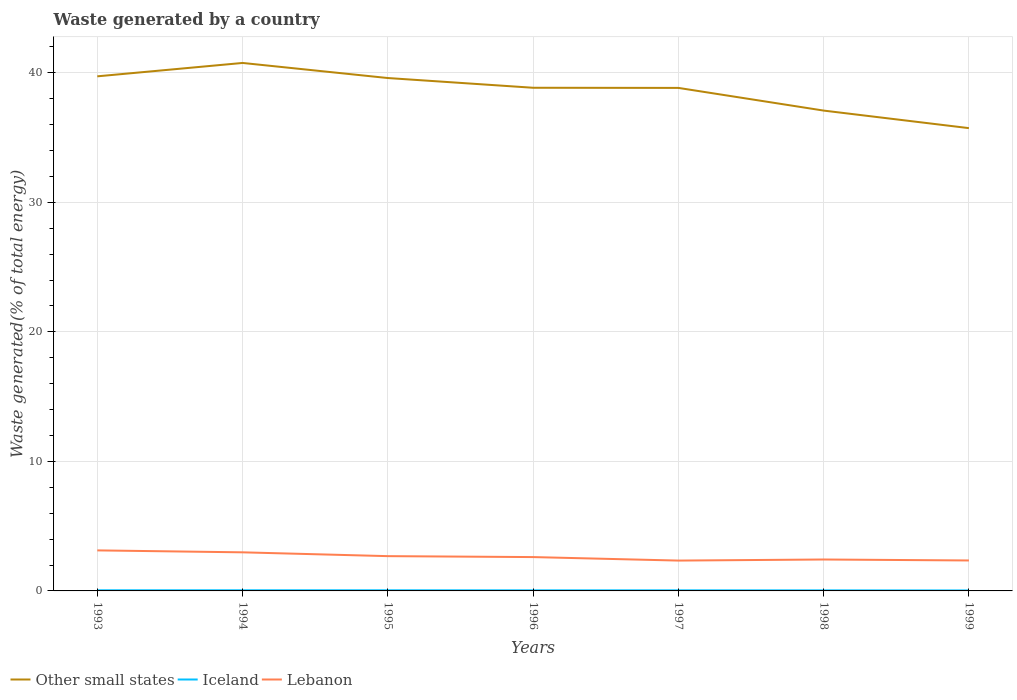How many different coloured lines are there?
Keep it short and to the point. 3. Across all years, what is the maximum total waste generated in Iceland?
Make the answer very short. 0.04. In which year was the total waste generated in Lebanon maximum?
Your answer should be compact. 1997. What is the total total waste generated in Other small states in the graph?
Provide a succinct answer. 2.64. What is the difference between the highest and the second highest total waste generated in Other small states?
Give a very brief answer. 5.03. How many lines are there?
Provide a short and direct response. 3. How many years are there in the graph?
Give a very brief answer. 7. What is the difference between two consecutive major ticks on the Y-axis?
Your answer should be compact. 10. Are the values on the major ticks of Y-axis written in scientific E-notation?
Offer a terse response. No. Does the graph contain any zero values?
Offer a terse response. No. What is the title of the graph?
Offer a very short reply. Waste generated by a country. What is the label or title of the Y-axis?
Make the answer very short. Waste generated(% of total energy). What is the Waste generated(% of total energy) of Other small states in 1993?
Your answer should be compact. 39.73. What is the Waste generated(% of total energy) of Iceland in 1993?
Make the answer very short. 0.05. What is the Waste generated(% of total energy) in Lebanon in 1993?
Provide a short and direct response. 3.13. What is the Waste generated(% of total energy) in Other small states in 1994?
Your response must be concise. 40.76. What is the Waste generated(% of total energy) in Iceland in 1994?
Keep it short and to the point. 0.05. What is the Waste generated(% of total energy) of Lebanon in 1994?
Provide a short and direct response. 2.98. What is the Waste generated(% of total energy) in Other small states in 1995?
Keep it short and to the point. 39.6. What is the Waste generated(% of total energy) in Iceland in 1995?
Keep it short and to the point. 0.05. What is the Waste generated(% of total energy) of Lebanon in 1995?
Offer a terse response. 2.69. What is the Waste generated(% of total energy) in Other small states in 1996?
Provide a short and direct response. 38.85. What is the Waste generated(% of total energy) in Iceland in 1996?
Offer a terse response. 0.05. What is the Waste generated(% of total energy) of Lebanon in 1996?
Make the answer very short. 2.61. What is the Waste generated(% of total energy) in Other small states in 1997?
Your answer should be compact. 38.84. What is the Waste generated(% of total energy) in Iceland in 1997?
Provide a short and direct response. 0.04. What is the Waste generated(% of total energy) in Lebanon in 1997?
Ensure brevity in your answer.  2.34. What is the Waste generated(% of total energy) of Other small states in 1998?
Your answer should be very brief. 37.09. What is the Waste generated(% of total energy) in Iceland in 1998?
Offer a very short reply. 0.04. What is the Waste generated(% of total energy) of Lebanon in 1998?
Keep it short and to the point. 2.43. What is the Waste generated(% of total energy) of Other small states in 1999?
Provide a short and direct response. 35.73. What is the Waste generated(% of total energy) in Iceland in 1999?
Your answer should be compact. 0.04. What is the Waste generated(% of total energy) in Lebanon in 1999?
Keep it short and to the point. 2.35. Across all years, what is the maximum Waste generated(% of total energy) in Other small states?
Offer a very short reply. 40.76. Across all years, what is the maximum Waste generated(% of total energy) in Iceland?
Ensure brevity in your answer.  0.05. Across all years, what is the maximum Waste generated(% of total energy) in Lebanon?
Your response must be concise. 3.13. Across all years, what is the minimum Waste generated(% of total energy) of Other small states?
Provide a succinct answer. 35.73. Across all years, what is the minimum Waste generated(% of total energy) of Iceland?
Give a very brief answer. 0.04. Across all years, what is the minimum Waste generated(% of total energy) of Lebanon?
Give a very brief answer. 2.34. What is the total Waste generated(% of total energy) of Other small states in the graph?
Keep it short and to the point. 270.6. What is the total Waste generated(% of total energy) of Iceland in the graph?
Your response must be concise. 0.31. What is the total Waste generated(% of total energy) in Lebanon in the graph?
Keep it short and to the point. 18.53. What is the difference between the Waste generated(% of total energy) of Other small states in 1993 and that in 1994?
Keep it short and to the point. -1.03. What is the difference between the Waste generated(% of total energy) in Lebanon in 1993 and that in 1994?
Your response must be concise. 0.15. What is the difference between the Waste generated(% of total energy) in Other small states in 1993 and that in 1995?
Your response must be concise. 0.13. What is the difference between the Waste generated(% of total energy) of Iceland in 1993 and that in 1995?
Make the answer very short. 0. What is the difference between the Waste generated(% of total energy) of Lebanon in 1993 and that in 1995?
Offer a very short reply. 0.44. What is the difference between the Waste generated(% of total energy) in Other small states in 1993 and that in 1996?
Your answer should be very brief. 0.88. What is the difference between the Waste generated(% of total energy) in Iceland in 1993 and that in 1996?
Your answer should be compact. 0. What is the difference between the Waste generated(% of total energy) in Lebanon in 1993 and that in 1996?
Provide a succinct answer. 0.52. What is the difference between the Waste generated(% of total energy) of Other small states in 1993 and that in 1997?
Offer a very short reply. 0.89. What is the difference between the Waste generated(% of total energy) of Iceland in 1993 and that in 1997?
Give a very brief answer. 0.01. What is the difference between the Waste generated(% of total energy) in Lebanon in 1993 and that in 1997?
Keep it short and to the point. 0.79. What is the difference between the Waste generated(% of total energy) in Other small states in 1993 and that in 1998?
Your answer should be very brief. 2.64. What is the difference between the Waste generated(% of total energy) in Iceland in 1993 and that in 1998?
Offer a very short reply. 0.01. What is the difference between the Waste generated(% of total energy) of Lebanon in 1993 and that in 1998?
Make the answer very short. 0.7. What is the difference between the Waste generated(% of total energy) of Other small states in 1993 and that in 1999?
Give a very brief answer. 4. What is the difference between the Waste generated(% of total energy) in Iceland in 1993 and that in 1999?
Keep it short and to the point. 0.01. What is the difference between the Waste generated(% of total energy) of Lebanon in 1993 and that in 1999?
Give a very brief answer. 0.78. What is the difference between the Waste generated(% of total energy) in Other small states in 1994 and that in 1995?
Keep it short and to the point. 1.16. What is the difference between the Waste generated(% of total energy) of Iceland in 1994 and that in 1995?
Your answer should be compact. 0. What is the difference between the Waste generated(% of total energy) of Lebanon in 1994 and that in 1995?
Your response must be concise. 0.29. What is the difference between the Waste generated(% of total energy) of Other small states in 1994 and that in 1996?
Your answer should be compact. 1.92. What is the difference between the Waste generated(% of total energy) in Iceland in 1994 and that in 1996?
Give a very brief answer. 0. What is the difference between the Waste generated(% of total energy) of Lebanon in 1994 and that in 1996?
Give a very brief answer. 0.37. What is the difference between the Waste generated(% of total energy) in Other small states in 1994 and that in 1997?
Offer a very short reply. 1.93. What is the difference between the Waste generated(% of total energy) in Iceland in 1994 and that in 1997?
Provide a succinct answer. 0. What is the difference between the Waste generated(% of total energy) of Lebanon in 1994 and that in 1997?
Give a very brief answer. 0.64. What is the difference between the Waste generated(% of total energy) in Other small states in 1994 and that in 1998?
Offer a terse response. 3.68. What is the difference between the Waste generated(% of total energy) of Iceland in 1994 and that in 1998?
Ensure brevity in your answer.  0.01. What is the difference between the Waste generated(% of total energy) in Lebanon in 1994 and that in 1998?
Keep it short and to the point. 0.55. What is the difference between the Waste generated(% of total energy) of Other small states in 1994 and that in 1999?
Offer a terse response. 5.03. What is the difference between the Waste generated(% of total energy) of Iceland in 1994 and that in 1999?
Your response must be concise. 0.01. What is the difference between the Waste generated(% of total energy) of Lebanon in 1994 and that in 1999?
Offer a terse response. 0.63. What is the difference between the Waste generated(% of total energy) of Other small states in 1995 and that in 1996?
Keep it short and to the point. 0.75. What is the difference between the Waste generated(% of total energy) in Iceland in 1995 and that in 1996?
Provide a short and direct response. 0. What is the difference between the Waste generated(% of total energy) of Lebanon in 1995 and that in 1996?
Provide a succinct answer. 0.07. What is the difference between the Waste generated(% of total energy) in Other small states in 1995 and that in 1997?
Provide a short and direct response. 0.76. What is the difference between the Waste generated(% of total energy) in Iceland in 1995 and that in 1997?
Keep it short and to the point. 0. What is the difference between the Waste generated(% of total energy) in Lebanon in 1995 and that in 1997?
Keep it short and to the point. 0.34. What is the difference between the Waste generated(% of total energy) of Other small states in 1995 and that in 1998?
Give a very brief answer. 2.51. What is the difference between the Waste generated(% of total energy) in Iceland in 1995 and that in 1998?
Keep it short and to the point. 0.01. What is the difference between the Waste generated(% of total energy) in Lebanon in 1995 and that in 1998?
Offer a very short reply. 0.26. What is the difference between the Waste generated(% of total energy) of Other small states in 1995 and that in 1999?
Ensure brevity in your answer.  3.87. What is the difference between the Waste generated(% of total energy) of Iceland in 1995 and that in 1999?
Your answer should be compact. 0.01. What is the difference between the Waste generated(% of total energy) in Lebanon in 1995 and that in 1999?
Provide a short and direct response. 0.33. What is the difference between the Waste generated(% of total energy) of Other small states in 1996 and that in 1997?
Keep it short and to the point. 0.01. What is the difference between the Waste generated(% of total energy) of Iceland in 1996 and that in 1997?
Ensure brevity in your answer.  0. What is the difference between the Waste generated(% of total energy) in Lebanon in 1996 and that in 1997?
Your response must be concise. 0.27. What is the difference between the Waste generated(% of total energy) in Other small states in 1996 and that in 1998?
Provide a short and direct response. 1.76. What is the difference between the Waste generated(% of total energy) in Iceland in 1996 and that in 1998?
Give a very brief answer. 0. What is the difference between the Waste generated(% of total energy) of Lebanon in 1996 and that in 1998?
Keep it short and to the point. 0.19. What is the difference between the Waste generated(% of total energy) in Other small states in 1996 and that in 1999?
Your answer should be compact. 3.12. What is the difference between the Waste generated(% of total energy) in Iceland in 1996 and that in 1999?
Offer a very short reply. 0.01. What is the difference between the Waste generated(% of total energy) in Lebanon in 1996 and that in 1999?
Give a very brief answer. 0.26. What is the difference between the Waste generated(% of total energy) of Other small states in 1997 and that in 1998?
Your answer should be very brief. 1.75. What is the difference between the Waste generated(% of total energy) in Iceland in 1997 and that in 1998?
Ensure brevity in your answer.  0. What is the difference between the Waste generated(% of total energy) of Lebanon in 1997 and that in 1998?
Ensure brevity in your answer.  -0.08. What is the difference between the Waste generated(% of total energy) of Other small states in 1997 and that in 1999?
Keep it short and to the point. 3.11. What is the difference between the Waste generated(% of total energy) of Iceland in 1997 and that in 1999?
Give a very brief answer. 0.01. What is the difference between the Waste generated(% of total energy) in Lebanon in 1997 and that in 1999?
Keep it short and to the point. -0.01. What is the difference between the Waste generated(% of total energy) of Other small states in 1998 and that in 1999?
Your response must be concise. 1.36. What is the difference between the Waste generated(% of total energy) of Iceland in 1998 and that in 1999?
Provide a succinct answer. 0.01. What is the difference between the Waste generated(% of total energy) in Lebanon in 1998 and that in 1999?
Offer a terse response. 0.08. What is the difference between the Waste generated(% of total energy) in Other small states in 1993 and the Waste generated(% of total energy) in Iceland in 1994?
Keep it short and to the point. 39.68. What is the difference between the Waste generated(% of total energy) of Other small states in 1993 and the Waste generated(% of total energy) of Lebanon in 1994?
Provide a short and direct response. 36.75. What is the difference between the Waste generated(% of total energy) in Iceland in 1993 and the Waste generated(% of total energy) in Lebanon in 1994?
Give a very brief answer. -2.93. What is the difference between the Waste generated(% of total energy) in Other small states in 1993 and the Waste generated(% of total energy) in Iceland in 1995?
Offer a very short reply. 39.68. What is the difference between the Waste generated(% of total energy) of Other small states in 1993 and the Waste generated(% of total energy) of Lebanon in 1995?
Keep it short and to the point. 37.05. What is the difference between the Waste generated(% of total energy) in Iceland in 1993 and the Waste generated(% of total energy) in Lebanon in 1995?
Provide a succinct answer. -2.64. What is the difference between the Waste generated(% of total energy) of Other small states in 1993 and the Waste generated(% of total energy) of Iceland in 1996?
Offer a very short reply. 39.69. What is the difference between the Waste generated(% of total energy) of Other small states in 1993 and the Waste generated(% of total energy) of Lebanon in 1996?
Keep it short and to the point. 37.12. What is the difference between the Waste generated(% of total energy) in Iceland in 1993 and the Waste generated(% of total energy) in Lebanon in 1996?
Offer a very short reply. -2.56. What is the difference between the Waste generated(% of total energy) in Other small states in 1993 and the Waste generated(% of total energy) in Iceland in 1997?
Give a very brief answer. 39.69. What is the difference between the Waste generated(% of total energy) in Other small states in 1993 and the Waste generated(% of total energy) in Lebanon in 1997?
Give a very brief answer. 37.39. What is the difference between the Waste generated(% of total energy) in Iceland in 1993 and the Waste generated(% of total energy) in Lebanon in 1997?
Your answer should be very brief. -2.29. What is the difference between the Waste generated(% of total energy) of Other small states in 1993 and the Waste generated(% of total energy) of Iceland in 1998?
Offer a terse response. 39.69. What is the difference between the Waste generated(% of total energy) in Other small states in 1993 and the Waste generated(% of total energy) in Lebanon in 1998?
Your answer should be compact. 37.31. What is the difference between the Waste generated(% of total energy) in Iceland in 1993 and the Waste generated(% of total energy) in Lebanon in 1998?
Keep it short and to the point. -2.38. What is the difference between the Waste generated(% of total energy) in Other small states in 1993 and the Waste generated(% of total energy) in Iceland in 1999?
Provide a short and direct response. 39.7. What is the difference between the Waste generated(% of total energy) in Other small states in 1993 and the Waste generated(% of total energy) in Lebanon in 1999?
Give a very brief answer. 37.38. What is the difference between the Waste generated(% of total energy) of Iceland in 1993 and the Waste generated(% of total energy) of Lebanon in 1999?
Provide a short and direct response. -2.3. What is the difference between the Waste generated(% of total energy) of Other small states in 1994 and the Waste generated(% of total energy) of Iceland in 1995?
Offer a terse response. 40.72. What is the difference between the Waste generated(% of total energy) of Other small states in 1994 and the Waste generated(% of total energy) of Lebanon in 1995?
Provide a short and direct response. 38.08. What is the difference between the Waste generated(% of total energy) in Iceland in 1994 and the Waste generated(% of total energy) in Lebanon in 1995?
Offer a terse response. -2.64. What is the difference between the Waste generated(% of total energy) of Other small states in 1994 and the Waste generated(% of total energy) of Iceland in 1996?
Keep it short and to the point. 40.72. What is the difference between the Waste generated(% of total energy) in Other small states in 1994 and the Waste generated(% of total energy) in Lebanon in 1996?
Ensure brevity in your answer.  38.15. What is the difference between the Waste generated(% of total energy) of Iceland in 1994 and the Waste generated(% of total energy) of Lebanon in 1996?
Keep it short and to the point. -2.56. What is the difference between the Waste generated(% of total energy) in Other small states in 1994 and the Waste generated(% of total energy) in Iceland in 1997?
Provide a short and direct response. 40.72. What is the difference between the Waste generated(% of total energy) in Other small states in 1994 and the Waste generated(% of total energy) in Lebanon in 1997?
Offer a very short reply. 38.42. What is the difference between the Waste generated(% of total energy) of Iceland in 1994 and the Waste generated(% of total energy) of Lebanon in 1997?
Offer a very short reply. -2.29. What is the difference between the Waste generated(% of total energy) in Other small states in 1994 and the Waste generated(% of total energy) in Iceland in 1998?
Give a very brief answer. 40.72. What is the difference between the Waste generated(% of total energy) of Other small states in 1994 and the Waste generated(% of total energy) of Lebanon in 1998?
Your response must be concise. 38.34. What is the difference between the Waste generated(% of total energy) in Iceland in 1994 and the Waste generated(% of total energy) in Lebanon in 1998?
Your answer should be very brief. -2.38. What is the difference between the Waste generated(% of total energy) of Other small states in 1994 and the Waste generated(% of total energy) of Iceland in 1999?
Make the answer very short. 40.73. What is the difference between the Waste generated(% of total energy) of Other small states in 1994 and the Waste generated(% of total energy) of Lebanon in 1999?
Offer a terse response. 38.41. What is the difference between the Waste generated(% of total energy) in Iceland in 1994 and the Waste generated(% of total energy) in Lebanon in 1999?
Your answer should be very brief. -2.3. What is the difference between the Waste generated(% of total energy) in Other small states in 1995 and the Waste generated(% of total energy) in Iceland in 1996?
Your answer should be very brief. 39.56. What is the difference between the Waste generated(% of total energy) of Other small states in 1995 and the Waste generated(% of total energy) of Lebanon in 1996?
Make the answer very short. 36.99. What is the difference between the Waste generated(% of total energy) in Iceland in 1995 and the Waste generated(% of total energy) in Lebanon in 1996?
Ensure brevity in your answer.  -2.57. What is the difference between the Waste generated(% of total energy) in Other small states in 1995 and the Waste generated(% of total energy) in Iceland in 1997?
Give a very brief answer. 39.56. What is the difference between the Waste generated(% of total energy) of Other small states in 1995 and the Waste generated(% of total energy) of Lebanon in 1997?
Your answer should be compact. 37.26. What is the difference between the Waste generated(% of total energy) in Iceland in 1995 and the Waste generated(% of total energy) in Lebanon in 1997?
Offer a terse response. -2.29. What is the difference between the Waste generated(% of total energy) of Other small states in 1995 and the Waste generated(% of total energy) of Iceland in 1998?
Offer a very short reply. 39.56. What is the difference between the Waste generated(% of total energy) in Other small states in 1995 and the Waste generated(% of total energy) in Lebanon in 1998?
Provide a succinct answer. 37.17. What is the difference between the Waste generated(% of total energy) in Iceland in 1995 and the Waste generated(% of total energy) in Lebanon in 1998?
Your response must be concise. -2.38. What is the difference between the Waste generated(% of total energy) of Other small states in 1995 and the Waste generated(% of total energy) of Iceland in 1999?
Your answer should be very brief. 39.56. What is the difference between the Waste generated(% of total energy) in Other small states in 1995 and the Waste generated(% of total energy) in Lebanon in 1999?
Keep it short and to the point. 37.25. What is the difference between the Waste generated(% of total energy) of Iceland in 1995 and the Waste generated(% of total energy) of Lebanon in 1999?
Offer a terse response. -2.3. What is the difference between the Waste generated(% of total energy) of Other small states in 1996 and the Waste generated(% of total energy) of Iceland in 1997?
Provide a short and direct response. 38.8. What is the difference between the Waste generated(% of total energy) in Other small states in 1996 and the Waste generated(% of total energy) in Lebanon in 1997?
Make the answer very short. 36.51. What is the difference between the Waste generated(% of total energy) in Iceland in 1996 and the Waste generated(% of total energy) in Lebanon in 1997?
Make the answer very short. -2.3. What is the difference between the Waste generated(% of total energy) in Other small states in 1996 and the Waste generated(% of total energy) in Iceland in 1998?
Give a very brief answer. 38.81. What is the difference between the Waste generated(% of total energy) in Other small states in 1996 and the Waste generated(% of total energy) in Lebanon in 1998?
Provide a short and direct response. 36.42. What is the difference between the Waste generated(% of total energy) of Iceland in 1996 and the Waste generated(% of total energy) of Lebanon in 1998?
Your response must be concise. -2.38. What is the difference between the Waste generated(% of total energy) in Other small states in 1996 and the Waste generated(% of total energy) in Iceland in 1999?
Offer a terse response. 38.81. What is the difference between the Waste generated(% of total energy) in Other small states in 1996 and the Waste generated(% of total energy) in Lebanon in 1999?
Your answer should be compact. 36.5. What is the difference between the Waste generated(% of total energy) of Iceland in 1996 and the Waste generated(% of total energy) of Lebanon in 1999?
Ensure brevity in your answer.  -2.31. What is the difference between the Waste generated(% of total energy) of Other small states in 1997 and the Waste generated(% of total energy) of Iceland in 1998?
Keep it short and to the point. 38.8. What is the difference between the Waste generated(% of total energy) of Other small states in 1997 and the Waste generated(% of total energy) of Lebanon in 1998?
Provide a short and direct response. 36.41. What is the difference between the Waste generated(% of total energy) in Iceland in 1997 and the Waste generated(% of total energy) in Lebanon in 1998?
Give a very brief answer. -2.38. What is the difference between the Waste generated(% of total energy) in Other small states in 1997 and the Waste generated(% of total energy) in Iceland in 1999?
Your response must be concise. 38.8. What is the difference between the Waste generated(% of total energy) in Other small states in 1997 and the Waste generated(% of total energy) in Lebanon in 1999?
Offer a terse response. 36.49. What is the difference between the Waste generated(% of total energy) in Iceland in 1997 and the Waste generated(% of total energy) in Lebanon in 1999?
Provide a short and direct response. -2.31. What is the difference between the Waste generated(% of total energy) in Other small states in 1998 and the Waste generated(% of total energy) in Iceland in 1999?
Ensure brevity in your answer.  37.05. What is the difference between the Waste generated(% of total energy) in Other small states in 1998 and the Waste generated(% of total energy) in Lebanon in 1999?
Give a very brief answer. 34.74. What is the difference between the Waste generated(% of total energy) of Iceland in 1998 and the Waste generated(% of total energy) of Lebanon in 1999?
Provide a succinct answer. -2.31. What is the average Waste generated(% of total energy) in Other small states per year?
Make the answer very short. 38.66. What is the average Waste generated(% of total energy) of Iceland per year?
Make the answer very short. 0.04. What is the average Waste generated(% of total energy) in Lebanon per year?
Give a very brief answer. 2.65. In the year 1993, what is the difference between the Waste generated(% of total energy) of Other small states and Waste generated(% of total energy) of Iceland?
Provide a succinct answer. 39.68. In the year 1993, what is the difference between the Waste generated(% of total energy) in Other small states and Waste generated(% of total energy) in Lebanon?
Offer a very short reply. 36.6. In the year 1993, what is the difference between the Waste generated(% of total energy) in Iceland and Waste generated(% of total energy) in Lebanon?
Make the answer very short. -3.08. In the year 1994, what is the difference between the Waste generated(% of total energy) in Other small states and Waste generated(% of total energy) in Iceland?
Keep it short and to the point. 40.72. In the year 1994, what is the difference between the Waste generated(% of total energy) in Other small states and Waste generated(% of total energy) in Lebanon?
Your response must be concise. 37.79. In the year 1994, what is the difference between the Waste generated(% of total energy) of Iceland and Waste generated(% of total energy) of Lebanon?
Give a very brief answer. -2.93. In the year 1995, what is the difference between the Waste generated(% of total energy) of Other small states and Waste generated(% of total energy) of Iceland?
Ensure brevity in your answer.  39.55. In the year 1995, what is the difference between the Waste generated(% of total energy) of Other small states and Waste generated(% of total energy) of Lebanon?
Offer a very short reply. 36.91. In the year 1995, what is the difference between the Waste generated(% of total energy) of Iceland and Waste generated(% of total energy) of Lebanon?
Provide a succinct answer. -2.64. In the year 1996, what is the difference between the Waste generated(% of total energy) of Other small states and Waste generated(% of total energy) of Iceland?
Your answer should be very brief. 38.8. In the year 1996, what is the difference between the Waste generated(% of total energy) in Other small states and Waste generated(% of total energy) in Lebanon?
Make the answer very short. 36.24. In the year 1996, what is the difference between the Waste generated(% of total energy) in Iceland and Waste generated(% of total energy) in Lebanon?
Offer a terse response. -2.57. In the year 1997, what is the difference between the Waste generated(% of total energy) of Other small states and Waste generated(% of total energy) of Iceland?
Make the answer very short. 38.79. In the year 1997, what is the difference between the Waste generated(% of total energy) of Other small states and Waste generated(% of total energy) of Lebanon?
Your response must be concise. 36.5. In the year 1997, what is the difference between the Waste generated(% of total energy) of Iceland and Waste generated(% of total energy) of Lebanon?
Offer a very short reply. -2.3. In the year 1998, what is the difference between the Waste generated(% of total energy) in Other small states and Waste generated(% of total energy) in Iceland?
Keep it short and to the point. 37.05. In the year 1998, what is the difference between the Waste generated(% of total energy) of Other small states and Waste generated(% of total energy) of Lebanon?
Provide a succinct answer. 34.66. In the year 1998, what is the difference between the Waste generated(% of total energy) in Iceland and Waste generated(% of total energy) in Lebanon?
Your response must be concise. -2.38. In the year 1999, what is the difference between the Waste generated(% of total energy) in Other small states and Waste generated(% of total energy) in Iceland?
Your response must be concise. 35.7. In the year 1999, what is the difference between the Waste generated(% of total energy) of Other small states and Waste generated(% of total energy) of Lebanon?
Give a very brief answer. 33.38. In the year 1999, what is the difference between the Waste generated(% of total energy) of Iceland and Waste generated(% of total energy) of Lebanon?
Your answer should be compact. -2.31. What is the ratio of the Waste generated(% of total energy) of Other small states in 1993 to that in 1994?
Your response must be concise. 0.97. What is the ratio of the Waste generated(% of total energy) of Lebanon in 1993 to that in 1994?
Make the answer very short. 1.05. What is the ratio of the Waste generated(% of total energy) of Iceland in 1993 to that in 1995?
Your answer should be very brief. 1.03. What is the ratio of the Waste generated(% of total energy) in Lebanon in 1993 to that in 1995?
Your answer should be compact. 1.17. What is the ratio of the Waste generated(% of total energy) of Other small states in 1993 to that in 1996?
Your answer should be very brief. 1.02. What is the ratio of the Waste generated(% of total energy) in Iceland in 1993 to that in 1996?
Provide a short and direct response. 1.09. What is the ratio of the Waste generated(% of total energy) of Lebanon in 1993 to that in 1996?
Make the answer very short. 1.2. What is the ratio of the Waste generated(% of total energy) in Other small states in 1993 to that in 1997?
Your answer should be very brief. 1.02. What is the ratio of the Waste generated(% of total energy) of Iceland in 1993 to that in 1997?
Provide a succinct answer. 1.11. What is the ratio of the Waste generated(% of total energy) of Lebanon in 1993 to that in 1997?
Provide a succinct answer. 1.34. What is the ratio of the Waste generated(% of total energy) of Other small states in 1993 to that in 1998?
Your answer should be compact. 1.07. What is the ratio of the Waste generated(% of total energy) of Iceland in 1993 to that in 1998?
Ensure brevity in your answer.  1.18. What is the ratio of the Waste generated(% of total energy) of Lebanon in 1993 to that in 1998?
Keep it short and to the point. 1.29. What is the ratio of the Waste generated(% of total energy) in Other small states in 1993 to that in 1999?
Make the answer very short. 1.11. What is the ratio of the Waste generated(% of total energy) of Iceland in 1993 to that in 1999?
Offer a very short reply. 1.36. What is the ratio of the Waste generated(% of total energy) of Lebanon in 1993 to that in 1999?
Keep it short and to the point. 1.33. What is the ratio of the Waste generated(% of total energy) of Other small states in 1994 to that in 1995?
Keep it short and to the point. 1.03. What is the ratio of the Waste generated(% of total energy) of Iceland in 1994 to that in 1995?
Make the answer very short. 1.03. What is the ratio of the Waste generated(% of total energy) of Lebanon in 1994 to that in 1995?
Make the answer very short. 1.11. What is the ratio of the Waste generated(% of total energy) in Other small states in 1994 to that in 1996?
Give a very brief answer. 1.05. What is the ratio of the Waste generated(% of total energy) in Iceland in 1994 to that in 1996?
Your answer should be compact. 1.09. What is the ratio of the Waste generated(% of total energy) of Lebanon in 1994 to that in 1996?
Offer a terse response. 1.14. What is the ratio of the Waste generated(% of total energy) in Other small states in 1994 to that in 1997?
Make the answer very short. 1.05. What is the ratio of the Waste generated(% of total energy) of Iceland in 1994 to that in 1997?
Keep it short and to the point. 1.11. What is the ratio of the Waste generated(% of total energy) of Lebanon in 1994 to that in 1997?
Give a very brief answer. 1.27. What is the ratio of the Waste generated(% of total energy) in Other small states in 1994 to that in 1998?
Your answer should be compact. 1.1. What is the ratio of the Waste generated(% of total energy) in Iceland in 1994 to that in 1998?
Provide a succinct answer. 1.18. What is the ratio of the Waste generated(% of total energy) in Lebanon in 1994 to that in 1998?
Your answer should be compact. 1.23. What is the ratio of the Waste generated(% of total energy) of Other small states in 1994 to that in 1999?
Ensure brevity in your answer.  1.14. What is the ratio of the Waste generated(% of total energy) of Iceland in 1994 to that in 1999?
Your answer should be compact. 1.36. What is the ratio of the Waste generated(% of total energy) of Lebanon in 1994 to that in 1999?
Provide a succinct answer. 1.27. What is the ratio of the Waste generated(% of total energy) of Other small states in 1995 to that in 1996?
Ensure brevity in your answer.  1.02. What is the ratio of the Waste generated(% of total energy) of Iceland in 1995 to that in 1996?
Your response must be concise. 1.06. What is the ratio of the Waste generated(% of total energy) of Lebanon in 1995 to that in 1996?
Make the answer very short. 1.03. What is the ratio of the Waste generated(% of total energy) of Other small states in 1995 to that in 1997?
Offer a very short reply. 1.02. What is the ratio of the Waste generated(% of total energy) in Iceland in 1995 to that in 1997?
Provide a short and direct response. 1.08. What is the ratio of the Waste generated(% of total energy) of Lebanon in 1995 to that in 1997?
Provide a short and direct response. 1.15. What is the ratio of the Waste generated(% of total energy) in Other small states in 1995 to that in 1998?
Make the answer very short. 1.07. What is the ratio of the Waste generated(% of total energy) of Iceland in 1995 to that in 1998?
Offer a very short reply. 1.14. What is the ratio of the Waste generated(% of total energy) in Lebanon in 1995 to that in 1998?
Your answer should be compact. 1.11. What is the ratio of the Waste generated(% of total energy) of Other small states in 1995 to that in 1999?
Keep it short and to the point. 1.11. What is the ratio of the Waste generated(% of total energy) in Iceland in 1995 to that in 1999?
Provide a short and direct response. 1.31. What is the ratio of the Waste generated(% of total energy) of Lebanon in 1995 to that in 1999?
Make the answer very short. 1.14. What is the ratio of the Waste generated(% of total energy) in Other small states in 1996 to that in 1997?
Keep it short and to the point. 1. What is the ratio of the Waste generated(% of total energy) in Iceland in 1996 to that in 1997?
Keep it short and to the point. 1.02. What is the ratio of the Waste generated(% of total energy) of Lebanon in 1996 to that in 1997?
Your answer should be very brief. 1.12. What is the ratio of the Waste generated(% of total energy) in Other small states in 1996 to that in 1998?
Offer a terse response. 1.05. What is the ratio of the Waste generated(% of total energy) in Iceland in 1996 to that in 1998?
Your answer should be very brief. 1.08. What is the ratio of the Waste generated(% of total energy) of Lebanon in 1996 to that in 1998?
Provide a short and direct response. 1.08. What is the ratio of the Waste generated(% of total energy) in Other small states in 1996 to that in 1999?
Your answer should be compact. 1.09. What is the ratio of the Waste generated(% of total energy) in Iceland in 1996 to that in 1999?
Your answer should be compact. 1.24. What is the ratio of the Waste generated(% of total energy) in Lebanon in 1996 to that in 1999?
Your answer should be compact. 1.11. What is the ratio of the Waste generated(% of total energy) in Other small states in 1997 to that in 1998?
Make the answer very short. 1.05. What is the ratio of the Waste generated(% of total energy) in Iceland in 1997 to that in 1998?
Your answer should be compact. 1.06. What is the ratio of the Waste generated(% of total energy) of Lebanon in 1997 to that in 1998?
Your answer should be compact. 0.97. What is the ratio of the Waste generated(% of total energy) in Other small states in 1997 to that in 1999?
Provide a short and direct response. 1.09. What is the ratio of the Waste generated(% of total energy) in Iceland in 1997 to that in 1999?
Your response must be concise. 1.22. What is the ratio of the Waste generated(% of total energy) in Lebanon in 1997 to that in 1999?
Give a very brief answer. 1. What is the ratio of the Waste generated(% of total energy) in Other small states in 1998 to that in 1999?
Offer a terse response. 1.04. What is the ratio of the Waste generated(% of total energy) in Iceland in 1998 to that in 1999?
Provide a succinct answer. 1.15. What is the ratio of the Waste generated(% of total energy) of Lebanon in 1998 to that in 1999?
Offer a very short reply. 1.03. What is the difference between the highest and the second highest Waste generated(% of total energy) in Other small states?
Your answer should be compact. 1.03. What is the difference between the highest and the second highest Waste generated(% of total energy) of Iceland?
Provide a succinct answer. 0. What is the difference between the highest and the second highest Waste generated(% of total energy) of Lebanon?
Keep it short and to the point. 0.15. What is the difference between the highest and the lowest Waste generated(% of total energy) in Other small states?
Your answer should be compact. 5.03. What is the difference between the highest and the lowest Waste generated(% of total energy) of Iceland?
Provide a short and direct response. 0.01. What is the difference between the highest and the lowest Waste generated(% of total energy) in Lebanon?
Provide a short and direct response. 0.79. 